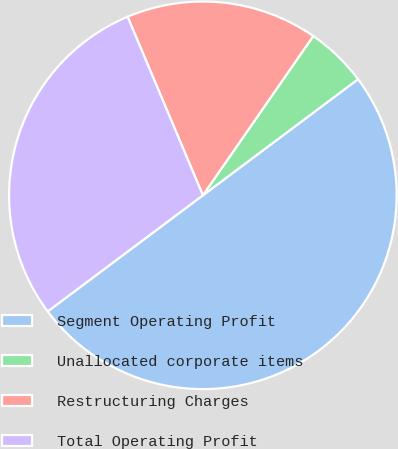Convert chart. <chart><loc_0><loc_0><loc_500><loc_500><pie_chart><fcel>Segment Operating Profit<fcel>Unallocated corporate items<fcel>Restructuring Charges<fcel>Total Operating Profit<nl><fcel>50.0%<fcel>5.13%<fcel>16.0%<fcel>28.87%<nl></chart> 